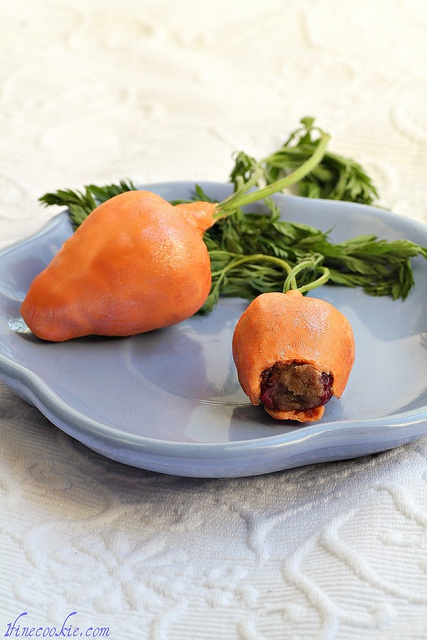Describe the objects in this image and their specific colors. I can see dining table in white, darkgray, gray, black, and red tones and hot dog in ivory, orange, maroon, red, and brown tones in this image. 